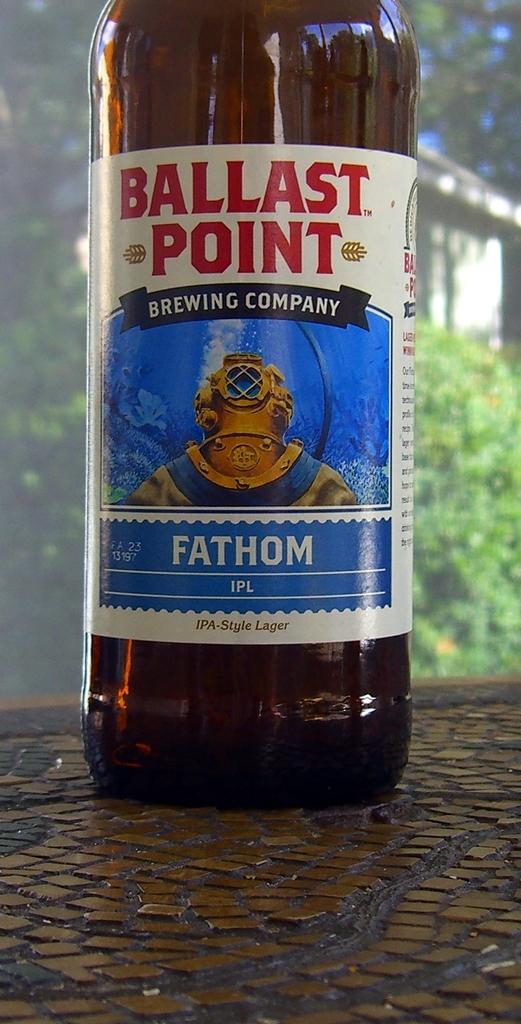What is the beer called?
Make the answer very short. Fathom. 